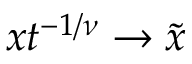Convert formula to latex. <formula><loc_0><loc_0><loc_500><loc_500>x t ^ { - 1 / \nu } \to \tilde { x }</formula> 